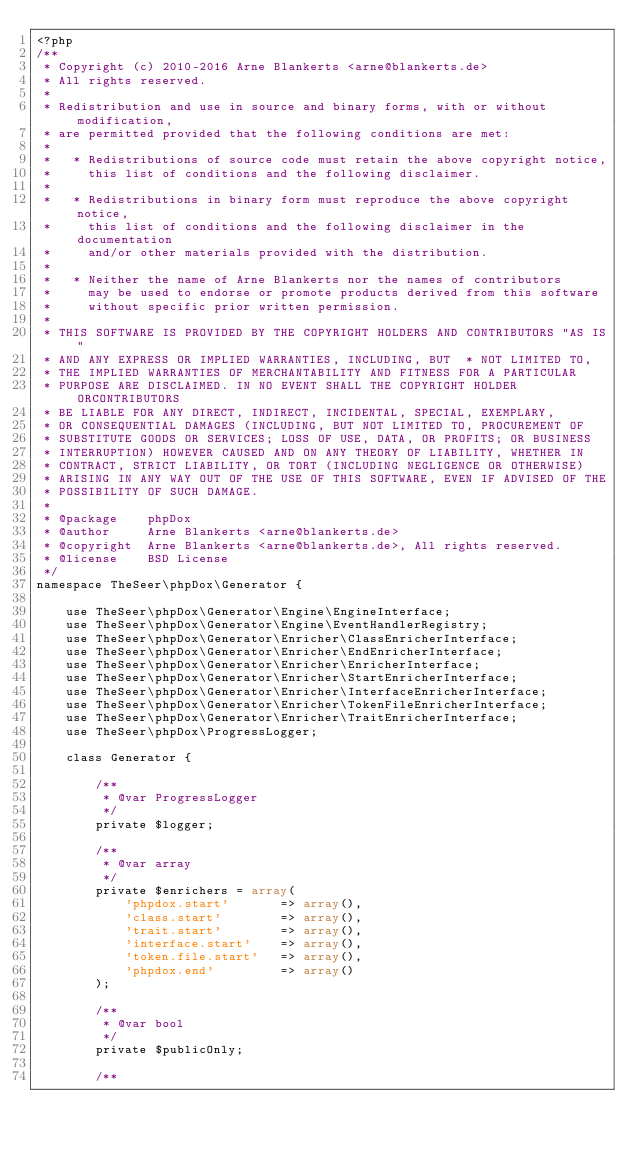<code> <loc_0><loc_0><loc_500><loc_500><_PHP_><?php
/**
 * Copyright (c) 2010-2016 Arne Blankerts <arne@blankerts.de>
 * All rights reserved.
 *
 * Redistribution and use in source and binary forms, with or without modification,
 * are permitted provided that the following conditions are met:
 *
 *   * Redistributions of source code must retain the above copyright notice,
 *     this list of conditions and the following disclaimer.
 *
 *   * Redistributions in binary form must reproduce the above copyright notice,
 *     this list of conditions and the following disclaimer in the documentation
 *     and/or other materials provided with the distribution.
 *
 *   * Neither the name of Arne Blankerts nor the names of contributors
 *     may be used to endorse or promote products derived from this software
 *     without specific prior written permission.
 *
 * THIS SOFTWARE IS PROVIDED BY THE COPYRIGHT HOLDERS AND CONTRIBUTORS "AS IS"
 * AND ANY EXPRESS OR IMPLIED WARRANTIES, INCLUDING, BUT  * NOT LIMITED TO,
 * THE IMPLIED WARRANTIES OF MERCHANTABILITY AND FITNESS FOR A PARTICULAR
 * PURPOSE ARE DISCLAIMED. IN NO EVENT SHALL THE COPYRIGHT HOLDER ORCONTRIBUTORS
 * BE LIABLE FOR ANY DIRECT, INDIRECT, INCIDENTAL, SPECIAL, EXEMPLARY,
 * OR CONSEQUENTIAL DAMAGES (INCLUDING, BUT NOT LIMITED TO, PROCUREMENT OF
 * SUBSTITUTE GOODS OR SERVICES; LOSS OF USE, DATA, OR PROFITS; OR BUSINESS
 * INTERRUPTION) HOWEVER CAUSED AND ON ANY THEORY OF LIABILITY, WHETHER IN
 * CONTRACT, STRICT LIABILITY, OR TORT (INCLUDING NEGLIGENCE OR OTHERWISE)
 * ARISING IN ANY WAY OUT OF THE USE OF THIS SOFTWARE, EVEN IF ADVISED OF THE
 * POSSIBILITY OF SUCH DAMAGE.
 *
 * @package    phpDox
 * @author     Arne Blankerts <arne@blankerts.de>
 * @copyright  Arne Blankerts <arne@blankerts.de>, All rights reserved.
 * @license    BSD License
 */
namespace TheSeer\phpDox\Generator {

    use TheSeer\phpDox\Generator\Engine\EngineInterface;
    use TheSeer\phpDox\Generator\Engine\EventHandlerRegistry;
    use TheSeer\phpDox\Generator\Enricher\ClassEnricherInterface;
    use TheSeer\phpDox\Generator\Enricher\EndEnricherInterface;
    use TheSeer\phpDox\Generator\Enricher\EnricherInterface;
    use TheSeer\phpDox\Generator\Enricher\StartEnricherInterface;
    use TheSeer\phpDox\Generator\Enricher\InterfaceEnricherInterface;
    use TheSeer\phpDox\Generator\Enricher\TokenFileEnricherInterface;
    use TheSeer\phpDox\Generator\Enricher\TraitEnricherInterface;
    use TheSeer\phpDox\ProgressLogger;

    class Generator {

        /**
         * @var ProgressLogger
         */
        private $logger;

        /**
         * @var array
         */
        private $enrichers = array(
            'phpdox.start'       => array(),
            'class.start'        => array(),
            'trait.start'        => array(),
            'interface.start'    => array(),
            'token.file.start'   => array(),
            'phpdox.end'         => array()
        );

        /**
         * @var bool
         */
        private $publicOnly;

        /**</code> 